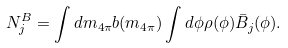Convert formula to latex. <formula><loc_0><loc_0><loc_500><loc_500>N _ { j } ^ { B } = \int d m _ { 4 \pi } b ( m _ { 4 \pi } ) \int d \phi \rho ( \phi ) \bar { B } _ { j } ( \phi ) .</formula> 